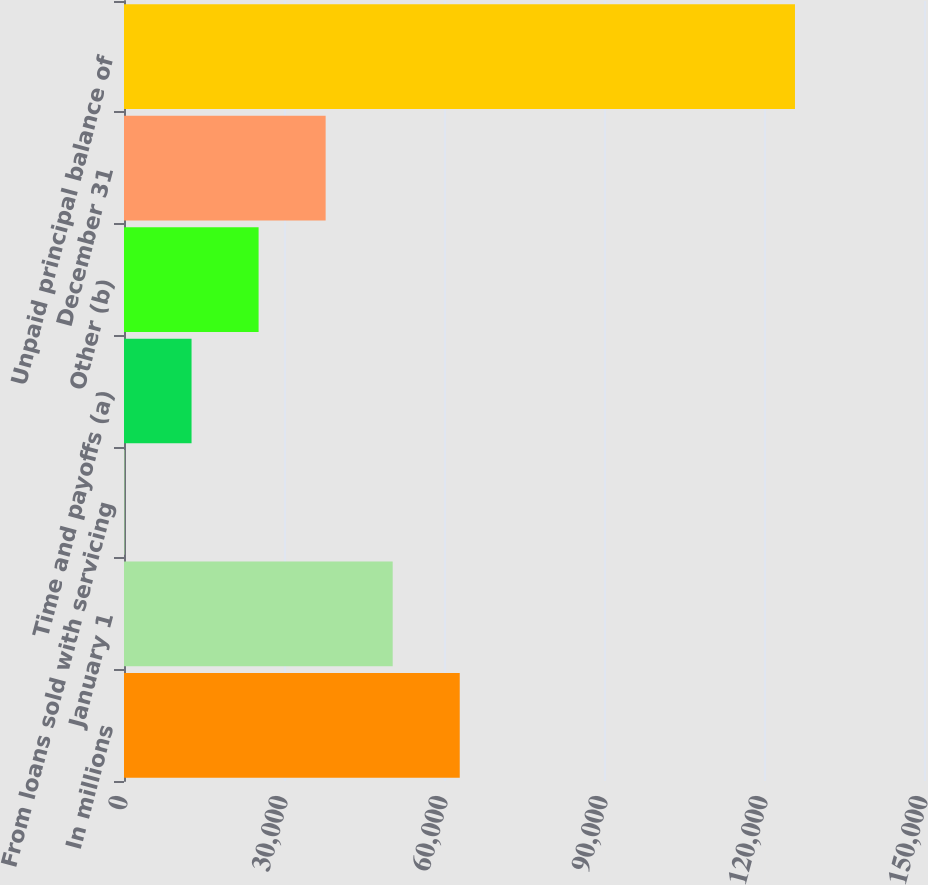Convert chart. <chart><loc_0><loc_0><loc_500><loc_500><bar_chart><fcel>In millions<fcel>January 1<fcel>From loans sold with servicing<fcel>Time and payoffs (a)<fcel>Other (b)<fcel>December 31<fcel>Unpaid principal balance of<nl><fcel>62950.5<fcel>50379.4<fcel>95<fcel>12666.1<fcel>25237.2<fcel>37808.3<fcel>125806<nl></chart> 